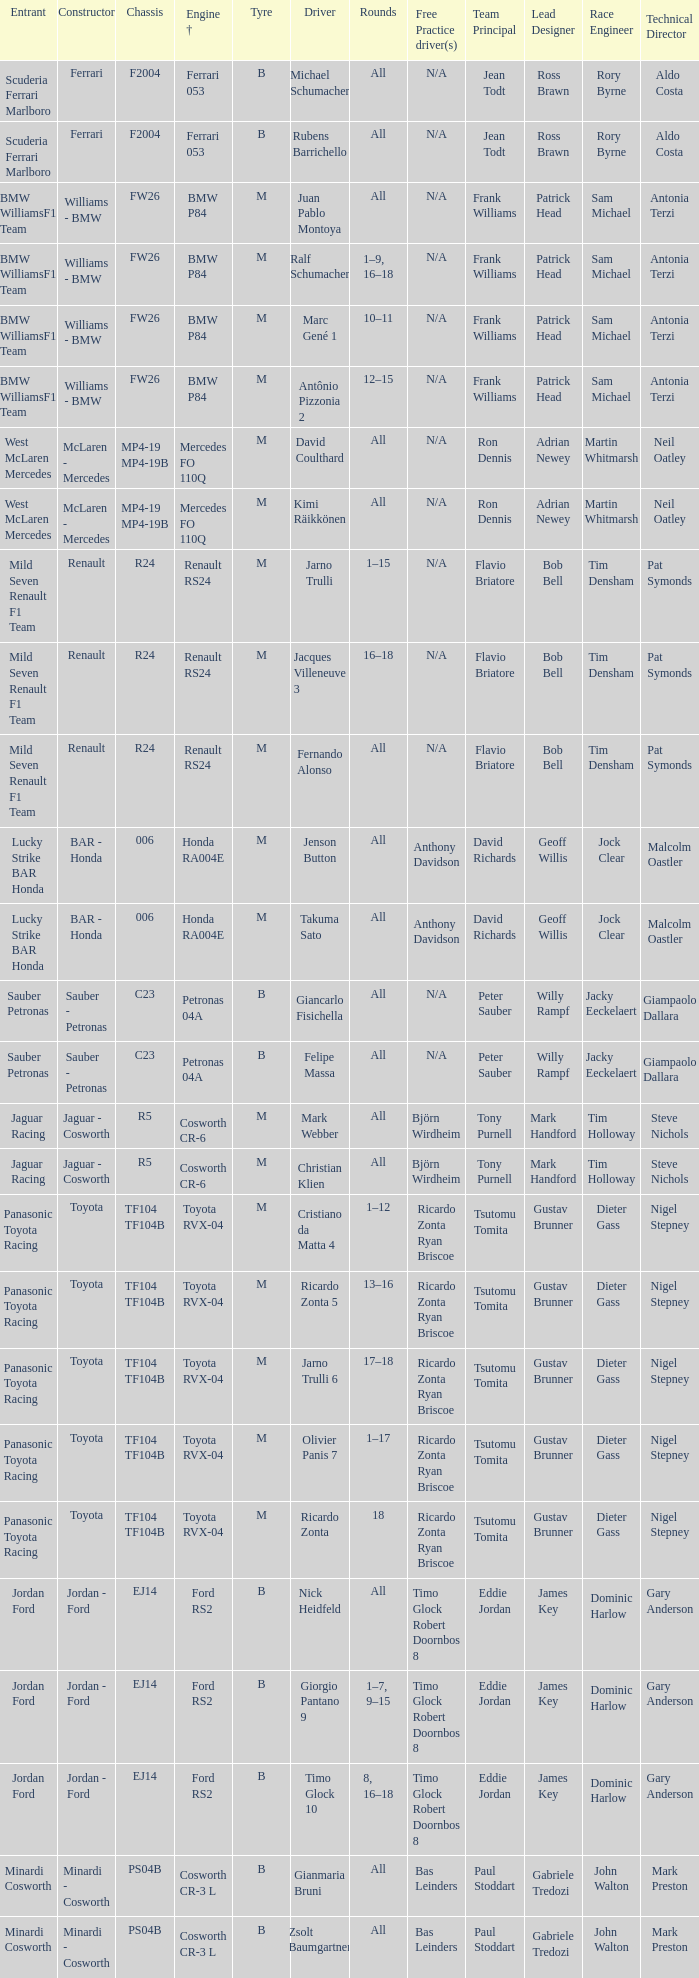What type of chassis does ricardo zonta possess? TF104 TF104B. 